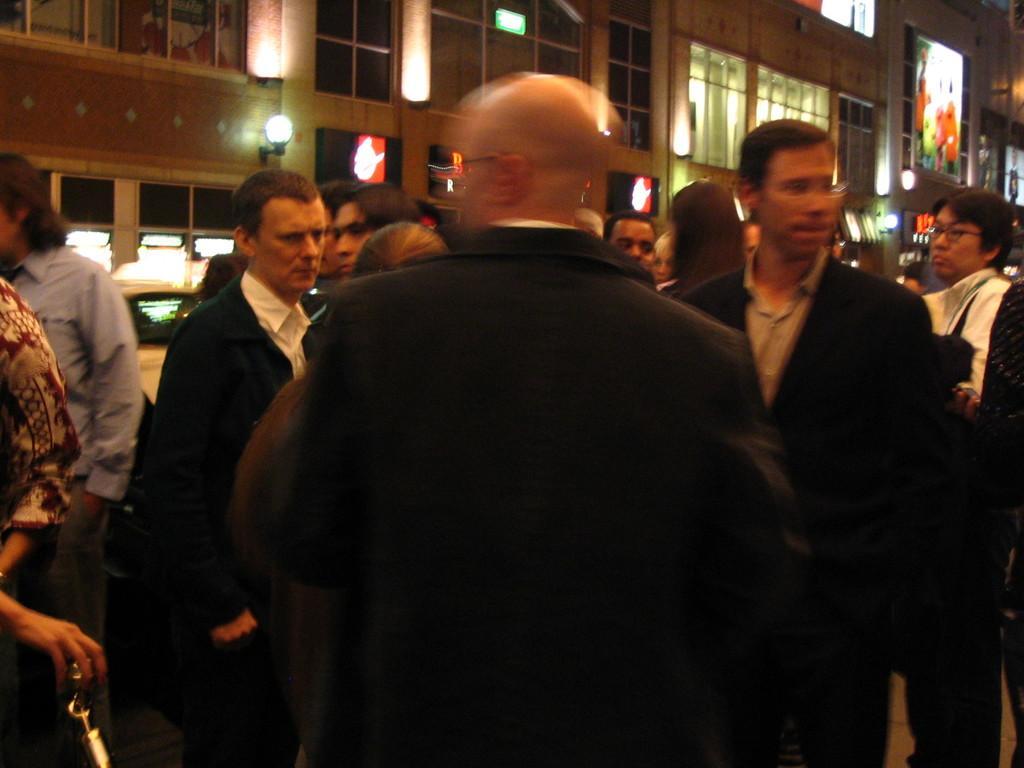Can you describe this image briefly? In this image, we can see a group of people wearing clothes and standing in front of the building. There is a light on the wall. 